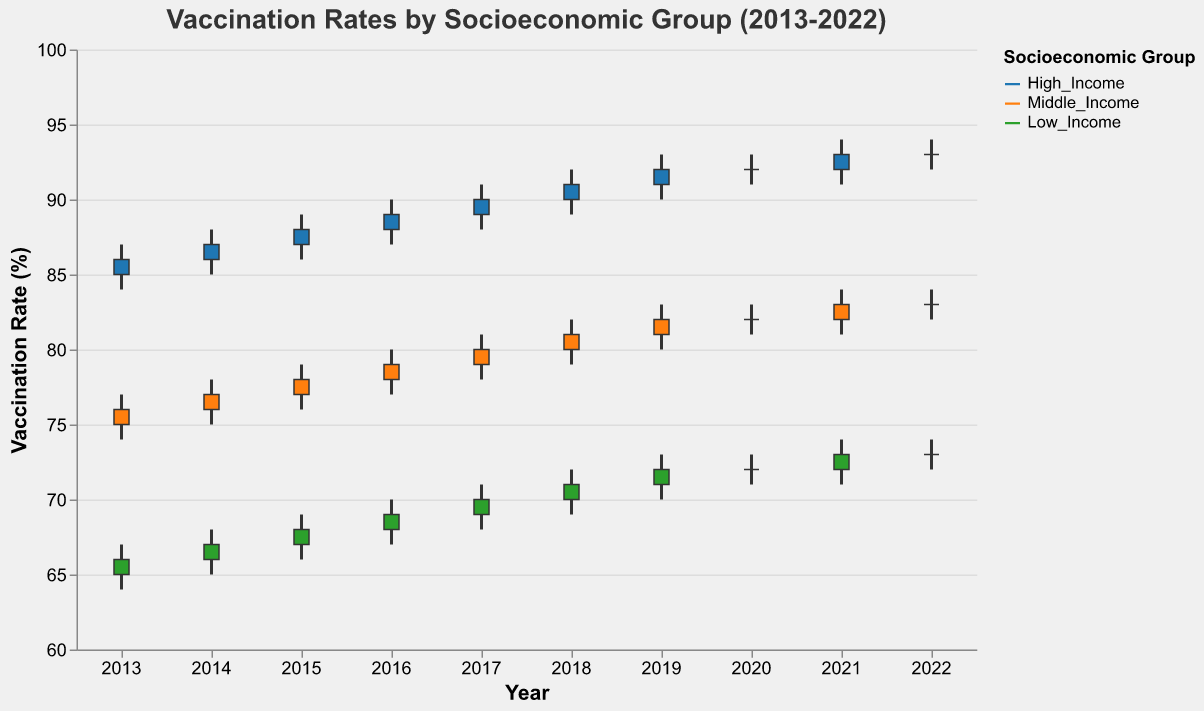What is the title of the figure? The title is displayed at the top of the figure and describes what the figure is about.
Answer: Vaccination Rates by Socioeconomic Group (2013-2022) What is the vaccination rate for the High Income group in 2018? Look at the candlestick representing the High Income group for the year 2018. The close value indicates the closing vaccination rate.
Answer: 91 Which socioeconomic group had the highest vaccination rate in 2022? Compare the close values of candlesticks for all three socioeconomic groups in 2022 to find the highest one.
Answer: High Income How did the vaccination rates for the Middle Income group change from 2019 to 2020? Check the opening and closing values for the Middle Income group in 2019 and 2020 and calculate the difference.
Answer: The rate stayed the same at 82% What was the lowest vaccination rate for the Low Income group in 2015? Look for the low value in the candlestick representing the Low Income group for the year 2015.
Answer: 66 What is the trend in vaccination rates for the High Income group over the decade? Observe the changes in the close values of the High Income group from 2013 to 2022 to describe the trend.
Answer: Increasing On average, did the Low Income group have an increasing or decreasing trend in vaccination rates from 2013 to 2022? Calculate the average change in the close values for the Low Income group from 2013 to 2022 to determine the trend direction.
Answer: Increasing In which year did the High Income group see the highest high value for vaccination rates? Compare the high values for the High Income group across all years to find the highest one.
Answer: 2021 How does the range of vaccination rates in 2017 compare between the Middle and Low Income groups? Calculate the range (high - low) for both Middle and Low Income groups in 2017 and compare them.
Answer: Middle Income: 3; Low Income: 3 What was the difference in the vaccination rates between the Close and Open values for the Low Income group in 2021? Subtract the Open value from the Close value for the Low Income group in 2021.
Answer: 1 